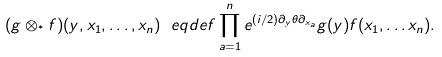Convert formula to latex. <formula><loc_0><loc_0><loc_500><loc_500>( g \otimes _ { ^ { * } } f ) ( y , x _ { 1 } , \dots , x _ { n } ) \ e q d e f \prod _ { a = 1 } ^ { n } e ^ { ( i / 2 ) \partial _ { y } \theta \partial _ { x _ { a } } } g ( y ) f ( x _ { 1 } , \dots x _ { n } ) .</formula> 